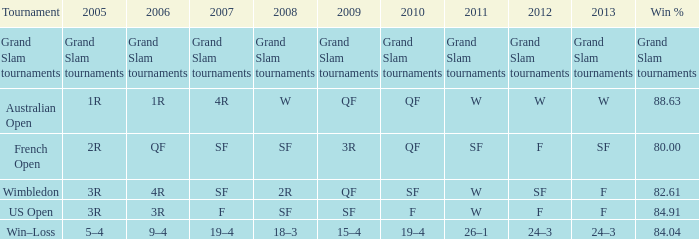WHat in 2005 has a Win % of 82.61? 3R. 